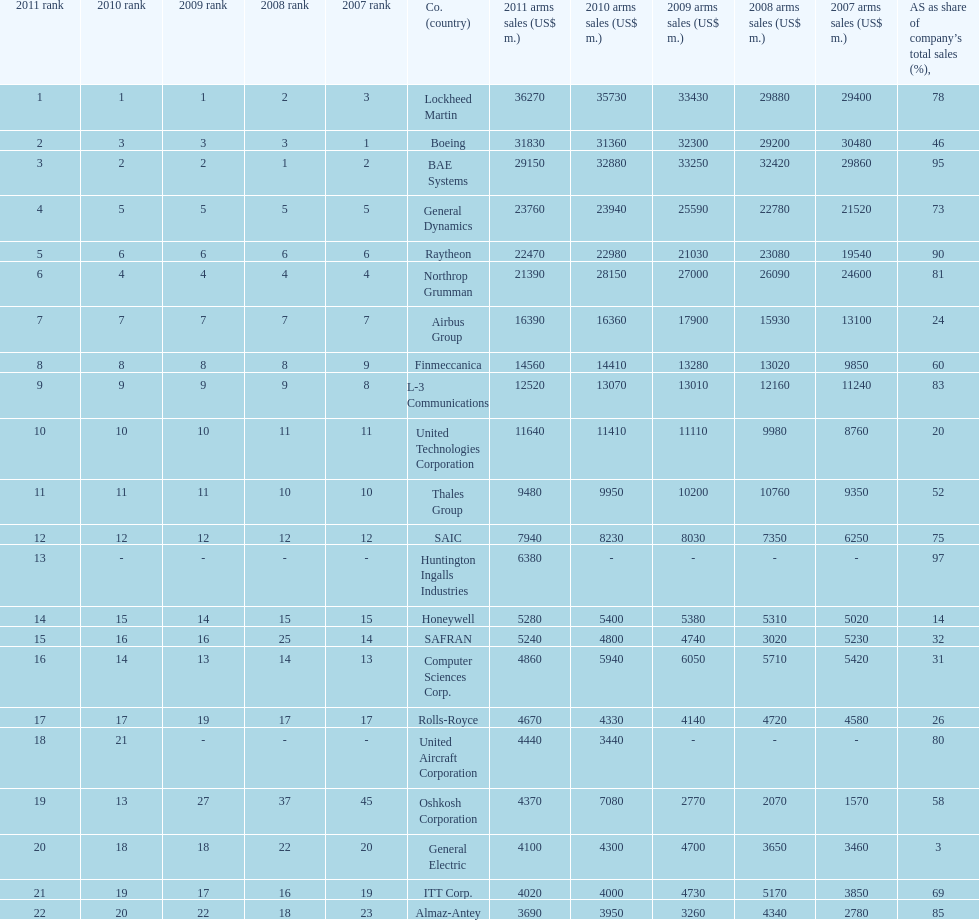Write the full table. {'header': ['2011 rank', '2010 rank', '2009 rank', '2008 rank', '2007 rank', 'Co. (country)', '2011 arms sales (US$ m.)', '2010 arms sales (US$ m.)', '2009 arms sales (US$ m.)', '2008 arms sales (US$ m.)', '2007 arms sales (US$ m.)', 'AS as share of company’s total sales (%),'], 'rows': [['1', '1', '1', '2', '3', 'Lockheed Martin', '36270', '35730', '33430', '29880', '29400', '78'], ['2', '3', '3', '3', '1', 'Boeing', '31830', '31360', '32300', '29200', '30480', '46'], ['3', '2', '2', '1', '2', 'BAE Systems', '29150', '32880', '33250', '32420', '29860', '95'], ['4', '5', '5', '5', '5', 'General Dynamics', '23760', '23940', '25590', '22780', '21520', '73'], ['5', '6', '6', '6', '6', 'Raytheon', '22470', '22980', '21030', '23080', '19540', '90'], ['6', '4', '4', '4', '4', 'Northrop Grumman', '21390', '28150', '27000', '26090', '24600', '81'], ['7', '7', '7', '7', '7', 'Airbus Group', '16390', '16360', '17900', '15930', '13100', '24'], ['8', '8', '8', '8', '9', 'Finmeccanica', '14560', '14410', '13280', '13020', '9850', '60'], ['9', '9', '9', '9', '8', 'L-3 Communications', '12520', '13070', '13010', '12160', '11240', '83'], ['10', '10', '10', '11', '11', 'United Technologies Corporation', '11640', '11410', '11110', '9980', '8760', '20'], ['11', '11', '11', '10', '10', 'Thales Group', '9480', '9950', '10200', '10760', '9350', '52'], ['12', '12', '12', '12', '12', 'SAIC', '7940', '8230', '8030', '7350', '6250', '75'], ['13', '-', '-', '-', '-', 'Huntington Ingalls Industries', '6380', '-', '-', '-', '-', '97'], ['14', '15', '14', '15', '15', 'Honeywell', '5280', '5400', '5380', '5310', '5020', '14'], ['15', '16', '16', '25', '14', 'SAFRAN', '5240', '4800', '4740', '3020', '5230', '32'], ['16', '14', '13', '14', '13', 'Computer Sciences Corp.', '4860', '5940', '6050', '5710', '5420', '31'], ['17', '17', '19', '17', '17', 'Rolls-Royce', '4670', '4330', '4140', '4720', '4580', '26'], ['18', '21', '-', '-', '-', 'United Aircraft Corporation', '4440', '3440', '-', '-', '-', '80'], ['19', '13', '27', '37', '45', 'Oshkosh Corporation', '4370', '7080', '2770', '2070', '1570', '58'], ['20', '18', '18', '22', '20', 'General Electric', '4100', '4300', '4700', '3650', '3460', '3'], ['21', '19', '17', '16', '19', 'ITT Corp.', '4020', '4000', '4730', '5170', '3850', '69'], ['22', '20', '22', '18', '23', 'Almaz-Antey', '3690', '3950', '3260', '4340', '2780', '85']]} Name all the companies whose arms sales as share of company's total sales is below 75%. Boeing, General Dynamics, Airbus Group, Finmeccanica, United Technologies Corporation, Thales Group, Honeywell, SAFRAN, Computer Sciences Corp., Rolls-Royce, Oshkosh Corporation, General Electric, ITT Corp. 